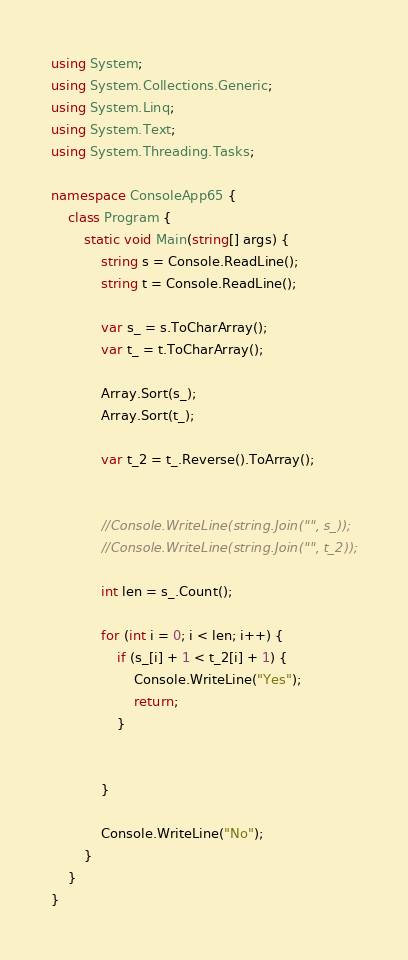<code> <loc_0><loc_0><loc_500><loc_500><_C#_>using System;
using System.Collections.Generic;
using System.Linq;
using System.Text;
using System.Threading.Tasks;

namespace ConsoleApp65 {
    class Program {
        static void Main(string[] args) {
            string s = Console.ReadLine();
            string t = Console.ReadLine();

            var s_ = s.ToCharArray();
            var t_ = t.ToCharArray();

            Array.Sort(s_);
            Array.Sort(t_);

            var t_2 = t_.Reverse().ToArray();


            //Console.WriteLine(string.Join("", s_));
            //Console.WriteLine(string.Join("", t_2));

            int len = s_.Count();

            for (int i = 0; i < len; i++) {
                if (s_[i] + 1 < t_2[i] + 1) {
                    Console.WriteLine("Yes");
                    return;
                }


            }

            Console.WriteLine("No");
        }
    }
}
</code> 